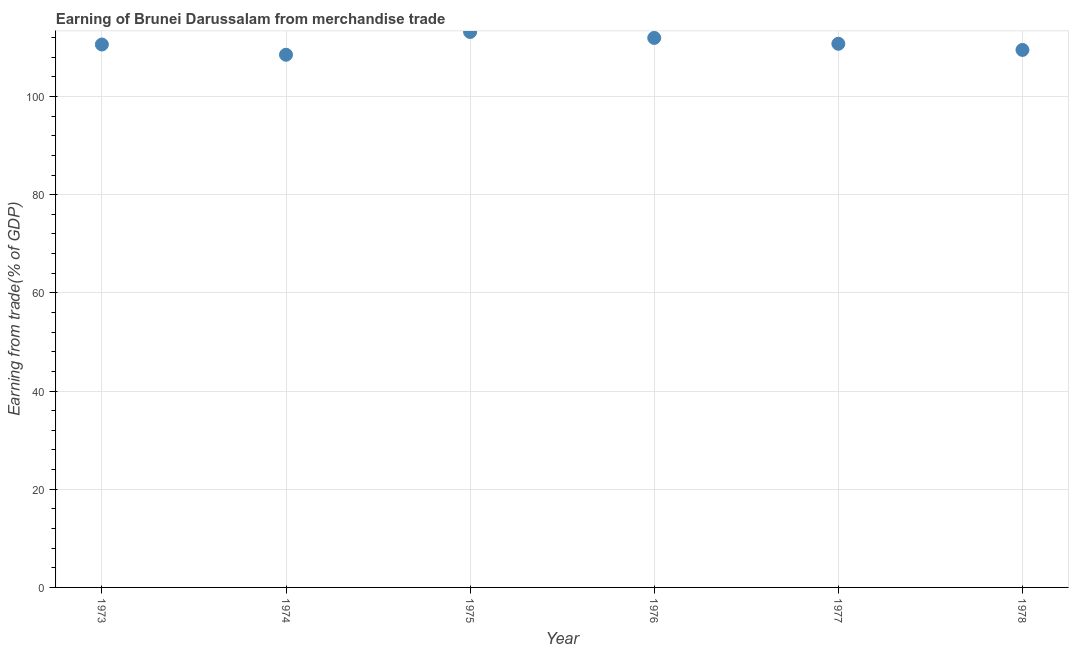What is the earning from merchandise trade in 1976?
Make the answer very short. 111.94. Across all years, what is the maximum earning from merchandise trade?
Ensure brevity in your answer.  113.16. Across all years, what is the minimum earning from merchandise trade?
Offer a terse response. 108.52. In which year was the earning from merchandise trade maximum?
Your answer should be compact. 1975. In which year was the earning from merchandise trade minimum?
Provide a succinct answer. 1974. What is the sum of the earning from merchandise trade?
Keep it short and to the point. 664.46. What is the difference between the earning from merchandise trade in 1975 and 1977?
Provide a short and direct response. 2.4. What is the average earning from merchandise trade per year?
Your answer should be very brief. 110.74. What is the median earning from merchandise trade?
Provide a short and direct response. 110.68. Do a majority of the years between 1974 and 1976 (inclusive) have earning from merchandise trade greater than 24 %?
Ensure brevity in your answer.  Yes. What is the ratio of the earning from merchandise trade in 1973 to that in 1977?
Make the answer very short. 1. Is the difference between the earning from merchandise trade in 1974 and 1976 greater than the difference between any two years?
Provide a short and direct response. No. What is the difference between the highest and the second highest earning from merchandise trade?
Provide a succinct answer. 1.21. Is the sum of the earning from merchandise trade in 1976 and 1977 greater than the maximum earning from merchandise trade across all years?
Ensure brevity in your answer.  Yes. What is the difference between the highest and the lowest earning from merchandise trade?
Offer a terse response. 4.64. Does the earning from merchandise trade monotonically increase over the years?
Ensure brevity in your answer.  No. How many dotlines are there?
Ensure brevity in your answer.  1. What is the difference between two consecutive major ticks on the Y-axis?
Give a very brief answer. 20. Does the graph contain any zero values?
Provide a short and direct response. No. Does the graph contain grids?
Ensure brevity in your answer.  Yes. What is the title of the graph?
Offer a terse response. Earning of Brunei Darussalam from merchandise trade. What is the label or title of the Y-axis?
Offer a terse response. Earning from trade(% of GDP). What is the Earning from trade(% of GDP) in 1973?
Give a very brief answer. 110.6. What is the Earning from trade(% of GDP) in 1974?
Provide a short and direct response. 108.52. What is the Earning from trade(% of GDP) in 1975?
Your answer should be compact. 113.16. What is the Earning from trade(% of GDP) in 1976?
Make the answer very short. 111.94. What is the Earning from trade(% of GDP) in 1977?
Make the answer very short. 110.75. What is the Earning from trade(% of GDP) in 1978?
Give a very brief answer. 109.5. What is the difference between the Earning from trade(% of GDP) in 1973 and 1974?
Offer a very short reply. 2.08. What is the difference between the Earning from trade(% of GDP) in 1973 and 1975?
Keep it short and to the point. -2.56. What is the difference between the Earning from trade(% of GDP) in 1973 and 1976?
Provide a short and direct response. -1.34. What is the difference between the Earning from trade(% of GDP) in 1973 and 1977?
Provide a short and direct response. -0.15. What is the difference between the Earning from trade(% of GDP) in 1973 and 1978?
Keep it short and to the point. 1.1. What is the difference between the Earning from trade(% of GDP) in 1974 and 1975?
Make the answer very short. -4.64. What is the difference between the Earning from trade(% of GDP) in 1974 and 1976?
Your answer should be compact. -3.43. What is the difference between the Earning from trade(% of GDP) in 1974 and 1977?
Provide a short and direct response. -2.23. What is the difference between the Earning from trade(% of GDP) in 1974 and 1978?
Offer a very short reply. -0.98. What is the difference between the Earning from trade(% of GDP) in 1975 and 1976?
Provide a short and direct response. 1.21. What is the difference between the Earning from trade(% of GDP) in 1975 and 1977?
Keep it short and to the point. 2.4. What is the difference between the Earning from trade(% of GDP) in 1975 and 1978?
Your answer should be very brief. 3.66. What is the difference between the Earning from trade(% of GDP) in 1976 and 1977?
Your answer should be very brief. 1.19. What is the difference between the Earning from trade(% of GDP) in 1976 and 1978?
Make the answer very short. 2.44. What is the difference between the Earning from trade(% of GDP) in 1977 and 1978?
Your response must be concise. 1.25. What is the ratio of the Earning from trade(% of GDP) in 1973 to that in 1975?
Provide a short and direct response. 0.98. What is the ratio of the Earning from trade(% of GDP) in 1973 to that in 1978?
Give a very brief answer. 1.01. What is the ratio of the Earning from trade(% of GDP) in 1974 to that in 1976?
Provide a succinct answer. 0.97. What is the ratio of the Earning from trade(% of GDP) in 1974 to that in 1977?
Ensure brevity in your answer.  0.98. What is the ratio of the Earning from trade(% of GDP) in 1975 to that in 1976?
Keep it short and to the point. 1.01. What is the ratio of the Earning from trade(% of GDP) in 1975 to that in 1978?
Provide a succinct answer. 1.03. What is the ratio of the Earning from trade(% of GDP) in 1976 to that in 1977?
Your answer should be very brief. 1.01. 